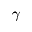Convert formula to latex. <formula><loc_0><loc_0><loc_500><loc_500>\gamma</formula> 